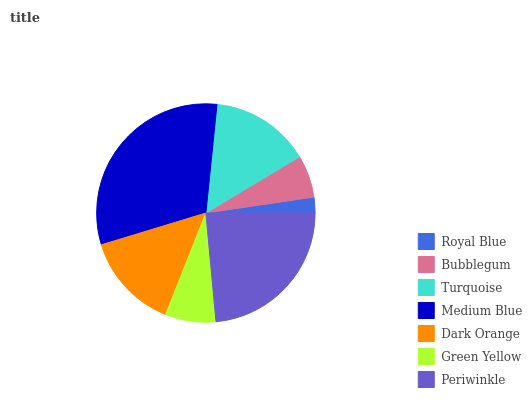Is Royal Blue the minimum?
Answer yes or no. Yes. Is Medium Blue the maximum?
Answer yes or no. Yes. Is Bubblegum the minimum?
Answer yes or no. No. Is Bubblegum the maximum?
Answer yes or no. No. Is Bubblegum greater than Royal Blue?
Answer yes or no. Yes. Is Royal Blue less than Bubblegum?
Answer yes or no. Yes. Is Royal Blue greater than Bubblegum?
Answer yes or no. No. Is Bubblegum less than Royal Blue?
Answer yes or no. No. Is Dark Orange the high median?
Answer yes or no. Yes. Is Dark Orange the low median?
Answer yes or no. Yes. Is Bubblegum the high median?
Answer yes or no. No. Is Green Yellow the low median?
Answer yes or no. No. 